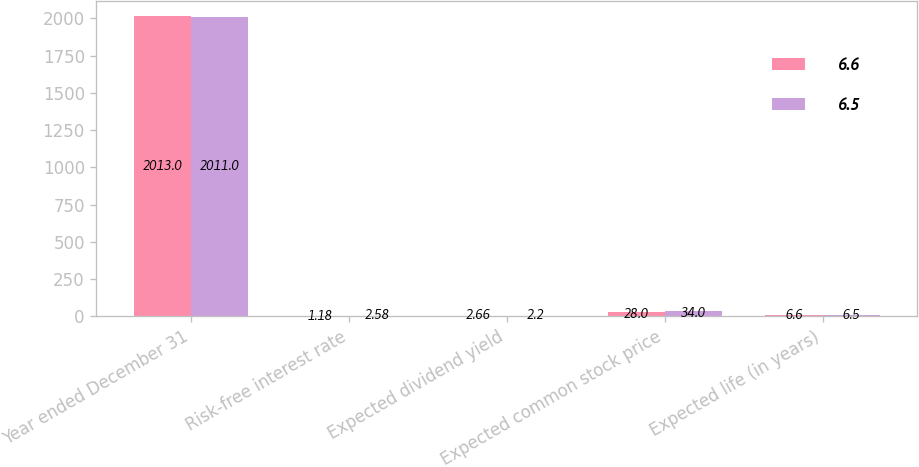Convert chart. <chart><loc_0><loc_0><loc_500><loc_500><stacked_bar_chart><ecel><fcel>Year ended December 31<fcel>Risk-free interest rate<fcel>Expected dividend yield<fcel>Expected common stock price<fcel>Expected life (in years)<nl><fcel>6.6<fcel>2013<fcel>1.18<fcel>2.66<fcel>28<fcel>6.6<nl><fcel>6.5<fcel>2011<fcel>2.58<fcel>2.2<fcel>34<fcel>6.5<nl></chart> 